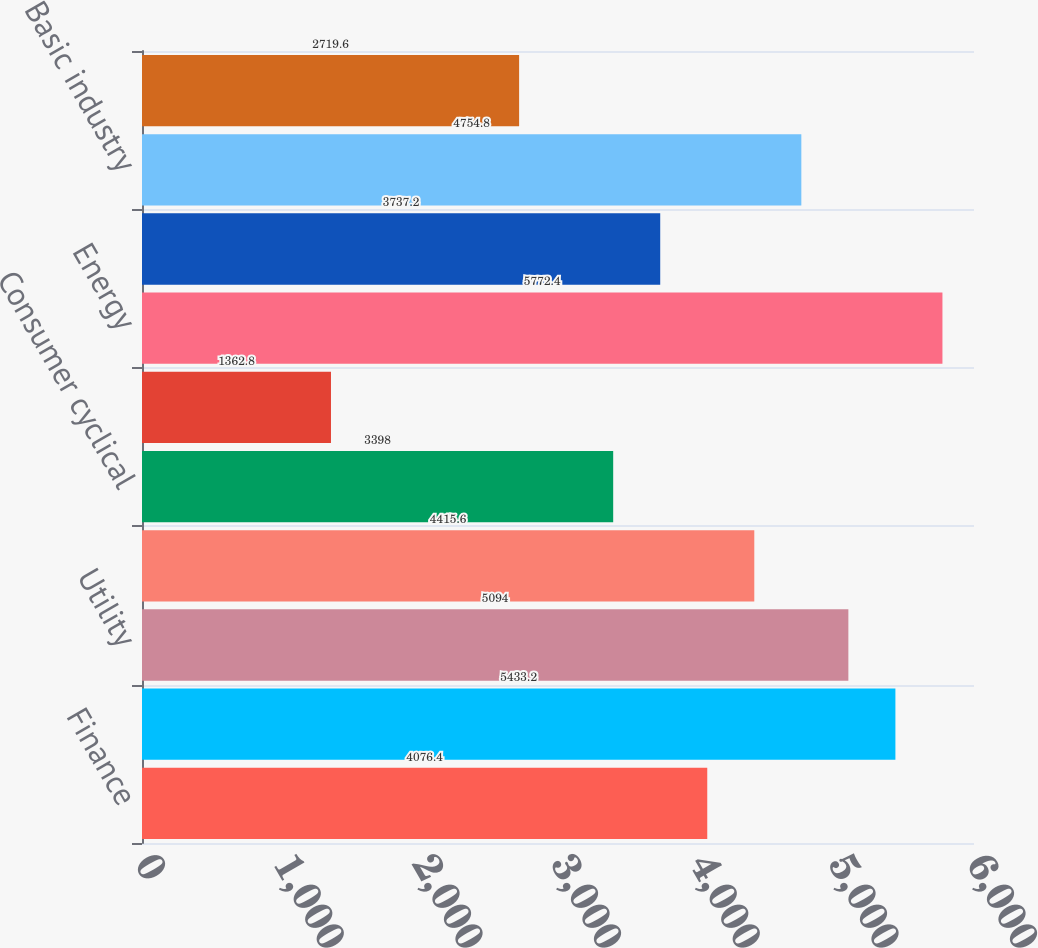Convert chart. <chart><loc_0><loc_0><loc_500><loc_500><bar_chart><fcel>Finance<fcel>Consumer non-cyclical<fcel>Utility<fcel>Capital goods<fcel>Consumer cyclical<fcel>Foreign agencies<fcel>Energy<fcel>Communications<fcel>Basic industry<fcel>Transportation<nl><fcel>4076.4<fcel>5433.2<fcel>5094<fcel>4415.6<fcel>3398<fcel>1362.8<fcel>5772.4<fcel>3737.2<fcel>4754.8<fcel>2719.6<nl></chart> 